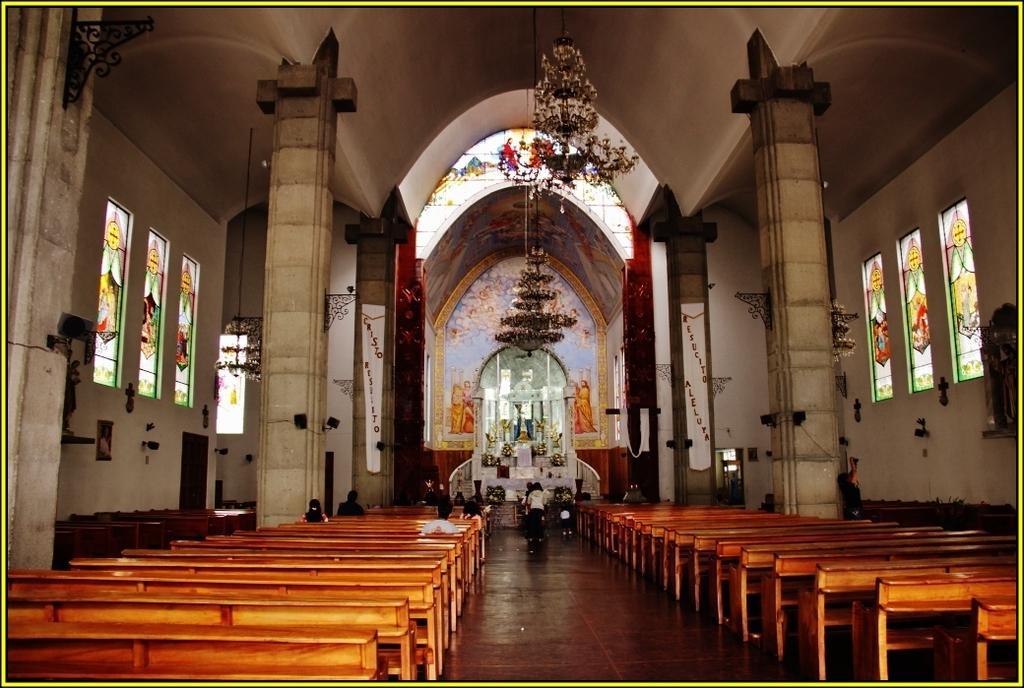How would you summarize this image in a sentence or two? In this image we can see inside of a church. There are few pillars in the image. There are few people sitting at the left side of the image. There are few people standing in the image. There are many benches in the image. We can see the painting on the walls and the glasses. There are few lamps in the image. We can see an idol in the image. 